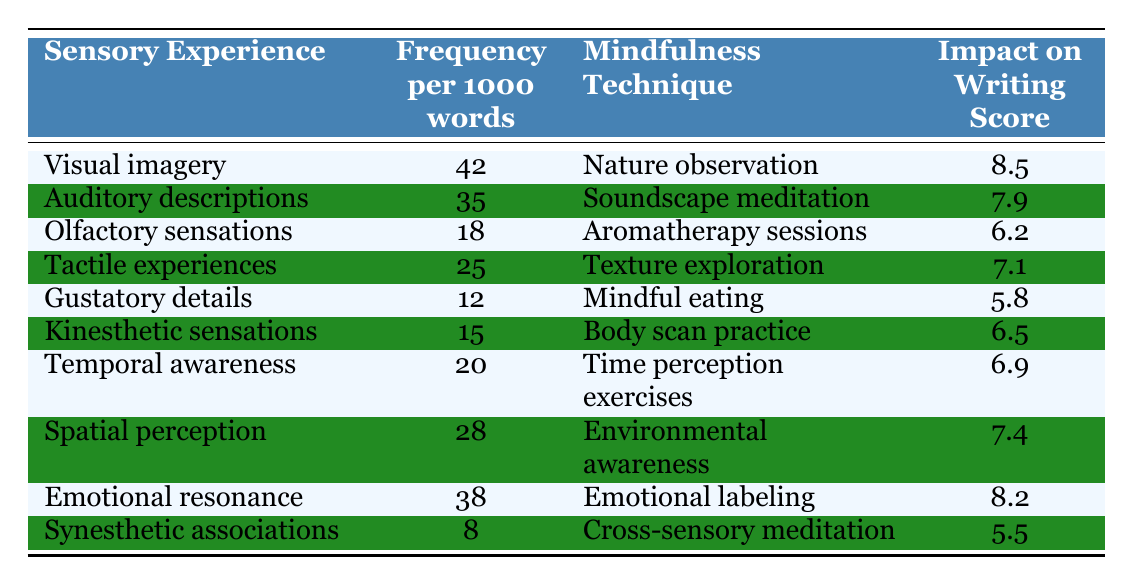What is the frequency of visual imagery per 1000 words? The table indicates that visual imagery has a frequency of 42 occurrences per 1000 words.
Answer: 42 Which sensory experience has the lowest frequency? By comparing the frequencies listed, synesthetic associations have the lowest frequency at 8 occurrences per 1000 words.
Answer: Synesthetic associations What mindfulness technique is associated with tactile experiences? The table states that texture exploration is the mindfulness technique linked to tactile experiences.
Answer: Texture exploration What is the impact on writing score for auditory descriptions? The writing score associated with auditory descriptions is found to be 7.9 based on the table.
Answer: 7.9 Is the impact on writing score higher for emotional resonance compared to kinesthetic sensations? Yes, emotional resonance has a score of 8.2, which is higher than the 6.5 score for kinesthetic sensations.
Answer: Yes Calculate the average frequency of all sensory experiences listed in the table. To find the average, sum the frequency values: (42 + 35 + 18 + 25 + 12 + 15 + 20 + 28 + 38 + 8) =  243. There are 10 data points, so the average is 243 / 10 = 24.3.
Answer: 24.3 What is the difference in impact on writing scores between visual imagery and gustatory details? Visual imagery has a score of 8.5 while gustatory details have a score of 5.8. The difference is 8.5 - 5.8 = 2.7.
Answer: 2.7 Which mindfulness technique is linked to the sensory experience with the highest frequency? Visual imagery has the highest frequency at 42, and it is associated with the mindfulness technique of nature observation.
Answer: Nature observation What is the total impact on writing score for all sensory experiences? Adding all the impact scores: (8.5 + 7.9 + 6.2 + 7.1 + 5.8 + 6.5 + 6.9 + 7.4 + 8.2 + 5.5) gives a total of 60.6.
Answer: 60.6 Is there a sensory experience that has a frequency greater than 30 with an impact score lower than 7? Yes, auditory descriptions have a frequency of 35 and an impact score of 7.9, and tactile experiences have a frequency of 25 with an impact score of 7.1, which does not meet the criteria, but olfactory sensations (18 frequency, 6.2 score) does, so the answer is "no."
Answer: No 